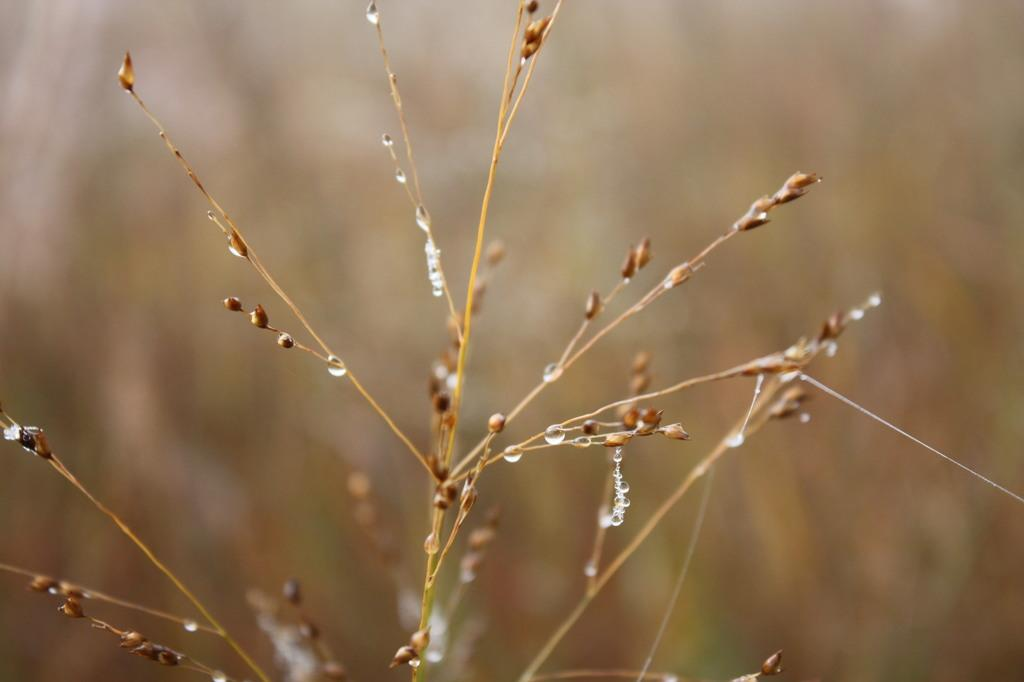What can be seen in the image? There are water drops in the image. Where are the water drops located? The water drops are on dry grass. What type of winter sport is being played in the image? There is no winter sport or any indication of winter in the image; it only shows water drops on dry grass. 